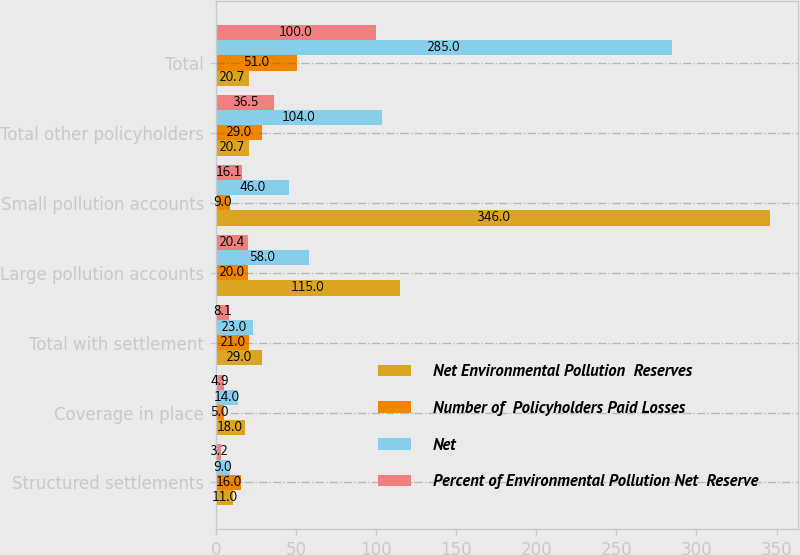<chart> <loc_0><loc_0><loc_500><loc_500><stacked_bar_chart><ecel><fcel>Structured settlements<fcel>Coverage in place<fcel>Total with settlement<fcel>Large pollution accounts<fcel>Small pollution accounts<fcel>Total other policyholders<fcel>Total<nl><fcel>Net Environmental Pollution  Reserves<fcel>11<fcel>18<fcel>29<fcel>115<fcel>346<fcel>20.7<fcel>20.7<nl><fcel>Number of  Policyholders Paid Losses<fcel>16<fcel>5<fcel>21<fcel>20<fcel>9<fcel>29<fcel>51<nl><fcel>Net<fcel>9<fcel>14<fcel>23<fcel>58<fcel>46<fcel>104<fcel>285<nl><fcel>Percent of Environmental Pollution Net  Reserve<fcel>3.2<fcel>4.9<fcel>8.1<fcel>20.4<fcel>16.1<fcel>36.5<fcel>100<nl></chart> 